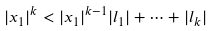<formula> <loc_0><loc_0><loc_500><loc_500>| x _ { 1 } | ^ { k } < | x _ { 1 } | ^ { k - 1 } | l _ { 1 } | + \dots + | l _ { k } |</formula> 